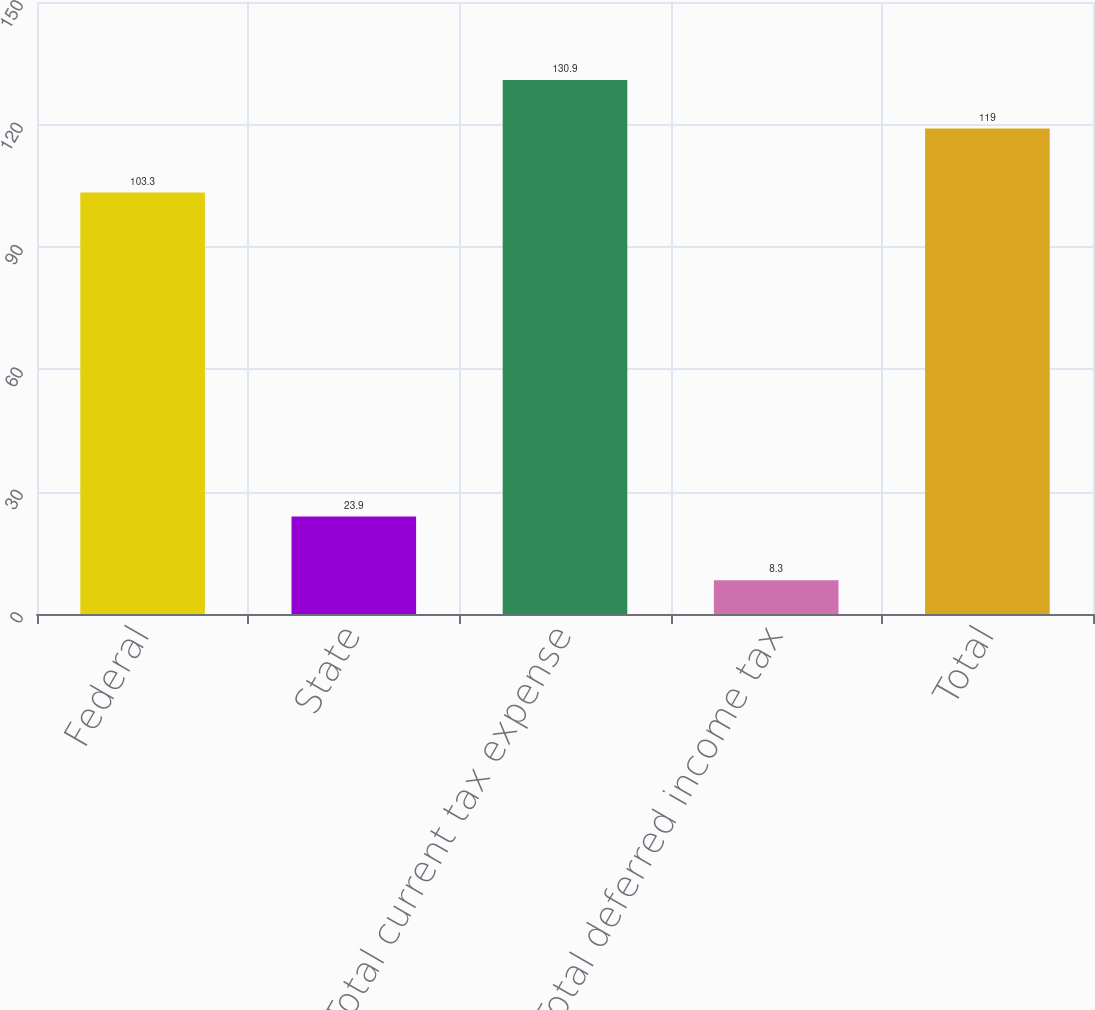<chart> <loc_0><loc_0><loc_500><loc_500><bar_chart><fcel>Federal<fcel>State<fcel>Total current tax expense<fcel>Total deferred income tax<fcel>Total<nl><fcel>103.3<fcel>23.9<fcel>130.9<fcel>8.3<fcel>119<nl></chart> 